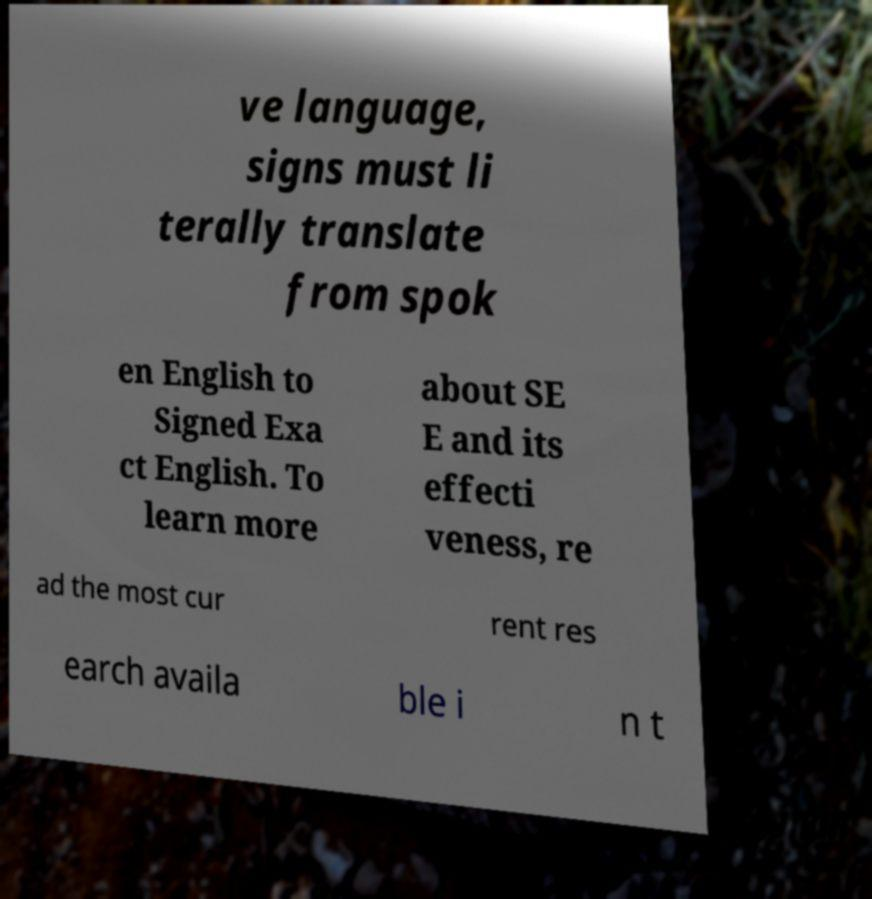Could you assist in decoding the text presented in this image and type it out clearly? ve language, signs must li terally translate from spok en English to Signed Exa ct English. To learn more about SE E and its effecti veness, re ad the most cur rent res earch availa ble i n t 